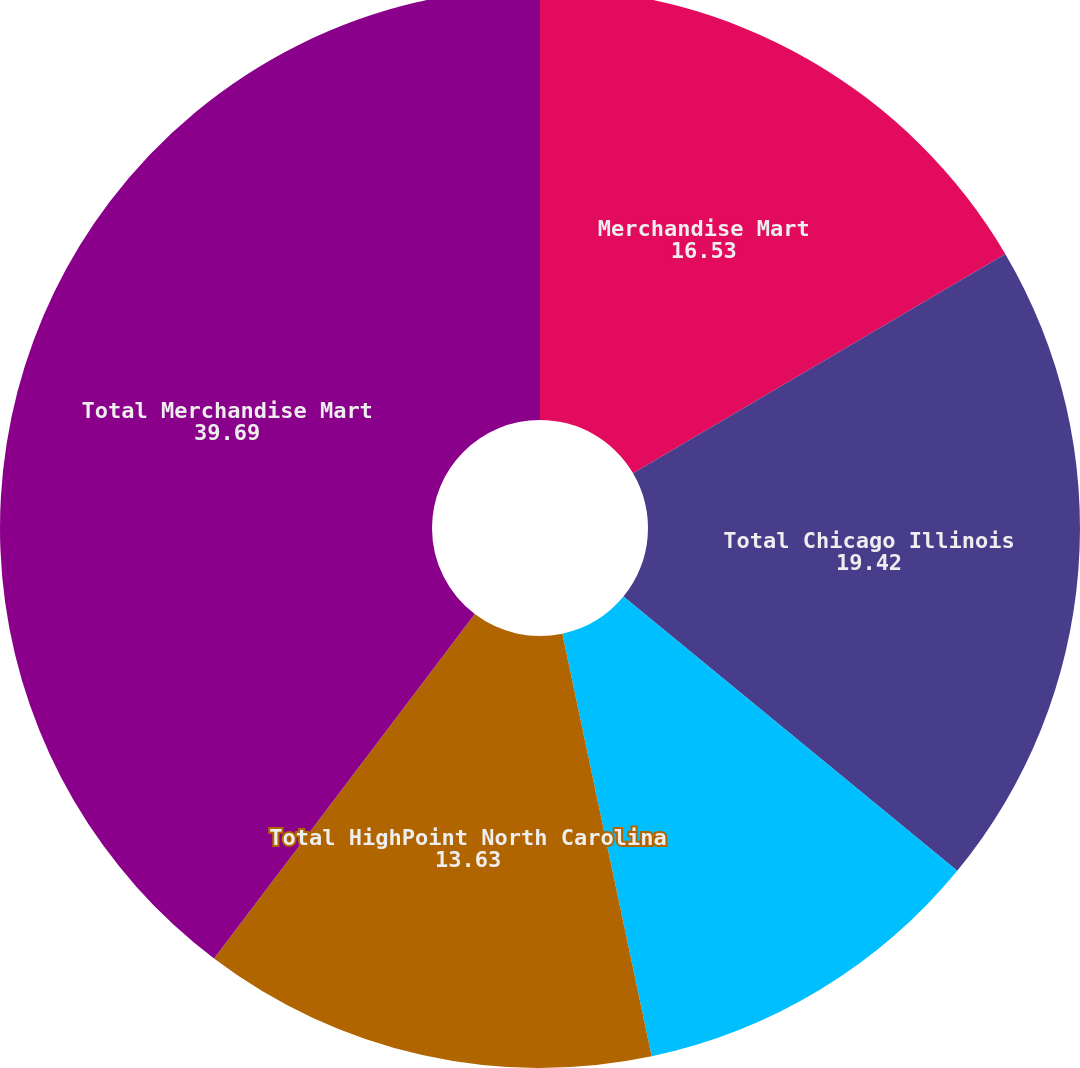Convert chart. <chart><loc_0><loc_0><loc_500><loc_500><pie_chart><fcel>Merchandise Mart<fcel>Total Chicago Illinois<fcel>Market Square Complex<fcel>Total HighPoint North Carolina<fcel>Total Merchandise Mart<nl><fcel>16.53%<fcel>19.42%<fcel>10.74%<fcel>13.63%<fcel>39.69%<nl></chart> 